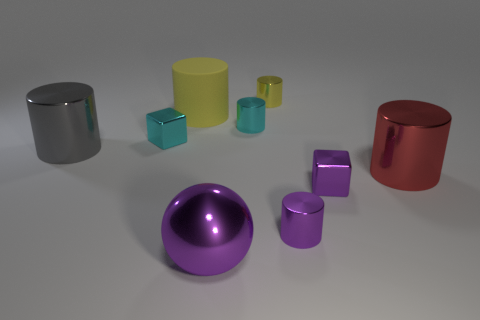Subtract all yellow cylinders. How many were subtracted if there are1yellow cylinders left? 1 Subtract all tiny purple metallic cylinders. How many cylinders are left? 5 Subtract all red spheres. How many yellow cylinders are left? 2 Subtract 1 cylinders. How many cylinders are left? 5 Subtract all yellow cylinders. How many cylinders are left? 4 Subtract all balls. How many objects are left? 8 Add 1 big purple things. How many big purple things are left? 2 Add 3 small purple shiny blocks. How many small purple shiny blocks exist? 4 Subtract 0 green balls. How many objects are left? 9 Subtract all yellow cylinders. Subtract all blue blocks. How many cylinders are left? 4 